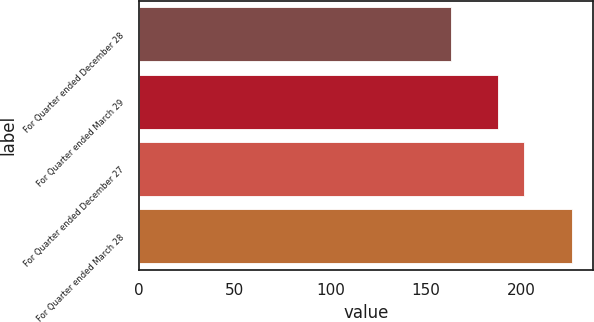Convert chart to OTSL. <chart><loc_0><loc_0><loc_500><loc_500><bar_chart><fcel>For Quarter ended December 28<fcel>For Quarter ended March 29<fcel>For Quarter ended December 27<fcel>For Quarter ended March 28<nl><fcel>162.95<fcel>187.64<fcel>201.04<fcel>226.21<nl></chart> 